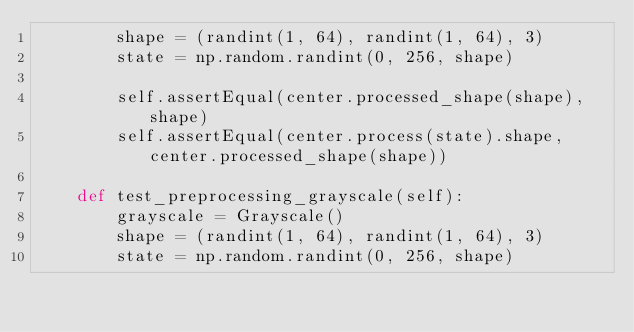<code> <loc_0><loc_0><loc_500><loc_500><_Python_>        shape = (randint(1, 64), randint(1, 64), 3)
        state = np.random.randint(0, 256, shape)

        self.assertEqual(center.processed_shape(shape), shape)
        self.assertEqual(center.process(state).shape, center.processed_shape(shape))

    def test_preprocessing_grayscale(self):
        grayscale = Grayscale()
        shape = (randint(1, 64), randint(1, 64), 3)
        state = np.random.randint(0, 256, shape)
</code> 